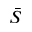Convert formula to latex. <formula><loc_0><loc_0><loc_500><loc_500>\bar { S }</formula> 